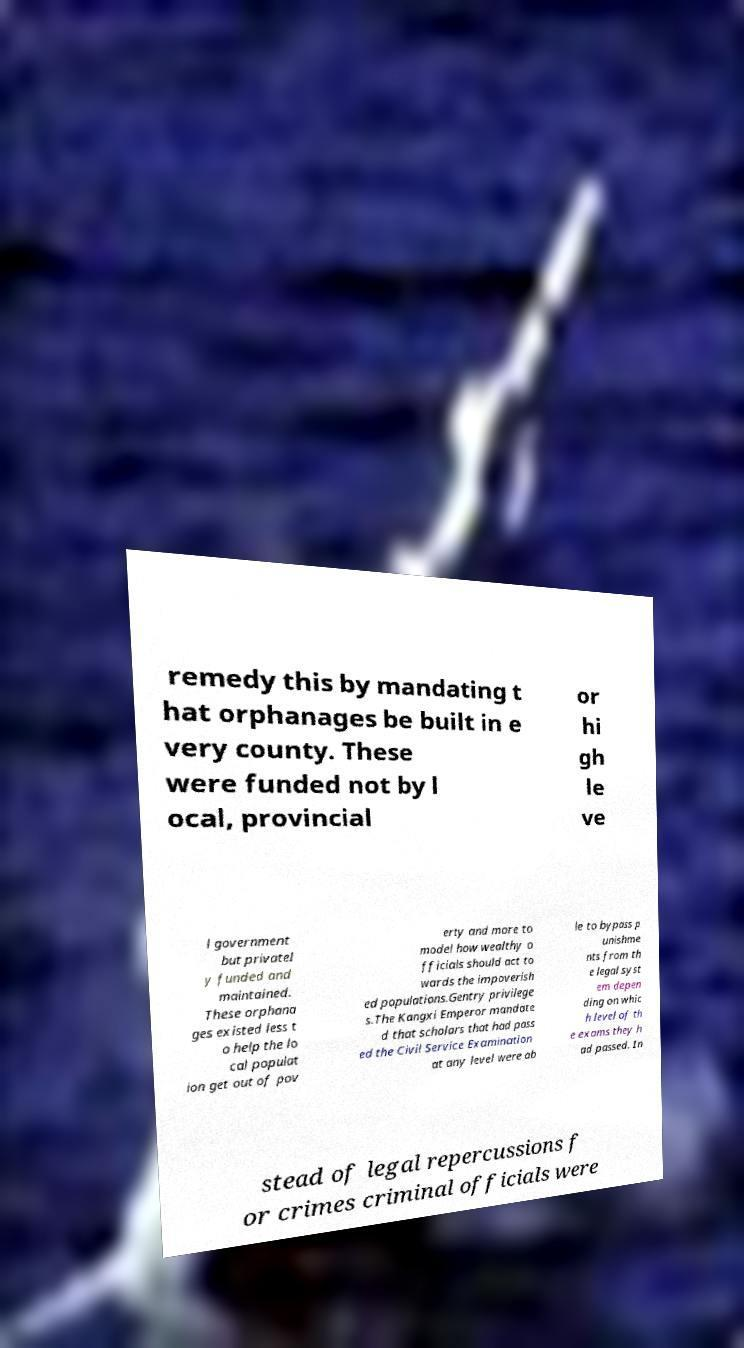Could you extract and type out the text from this image? remedy this by mandating t hat orphanages be built in e very county. These were funded not by l ocal, provincial or hi gh le ve l government but privatel y funded and maintained. These orphana ges existed less t o help the lo cal populat ion get out of pov erty and more to model how wealthy o fficials should act to wards the impoverish ed populations.Gentry privilege s.The Kangxi Emperor mandate d that scholars that had pass ed the Civil Service Examination at any level were ab le to bypass p unishme nts from th e legal syst em depen ding on whic h level of th e exams they h ad passed. In stead of legal repercussions f or crimes criminal officials were 